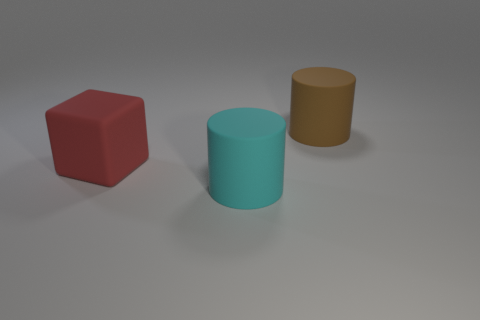Add 3 large cyan objects. How many objects exist? 6 Subtract all cubes. How many objects are left? 2 Subtract all rubber cylinders. Subtract all gray shiny blocks. How many objects are left? 1 Add 3 large red rubber cubes. How many large red rubber cubes are left? 4 Add 3 rubber cylinders. How many rubber cylinders exist? 5 Subtract 0 cyan blocks. How many objects are left? 3 